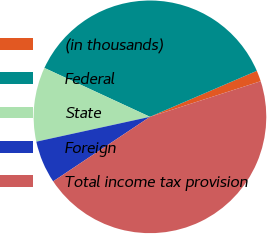Convert chart to OTSL. <chart><loc_0><loc_0><loc_500><loc_500><pie_chart><fcel>(in thousands)<fcel>Federal<fcel>State<fcel>Foreign<fcel>Total income tax provision<nl><fcel>1.52%<fcel>36.63%<fcel>10.33%<fcel>5.93%<fcel>45.6%<nl></chart> 